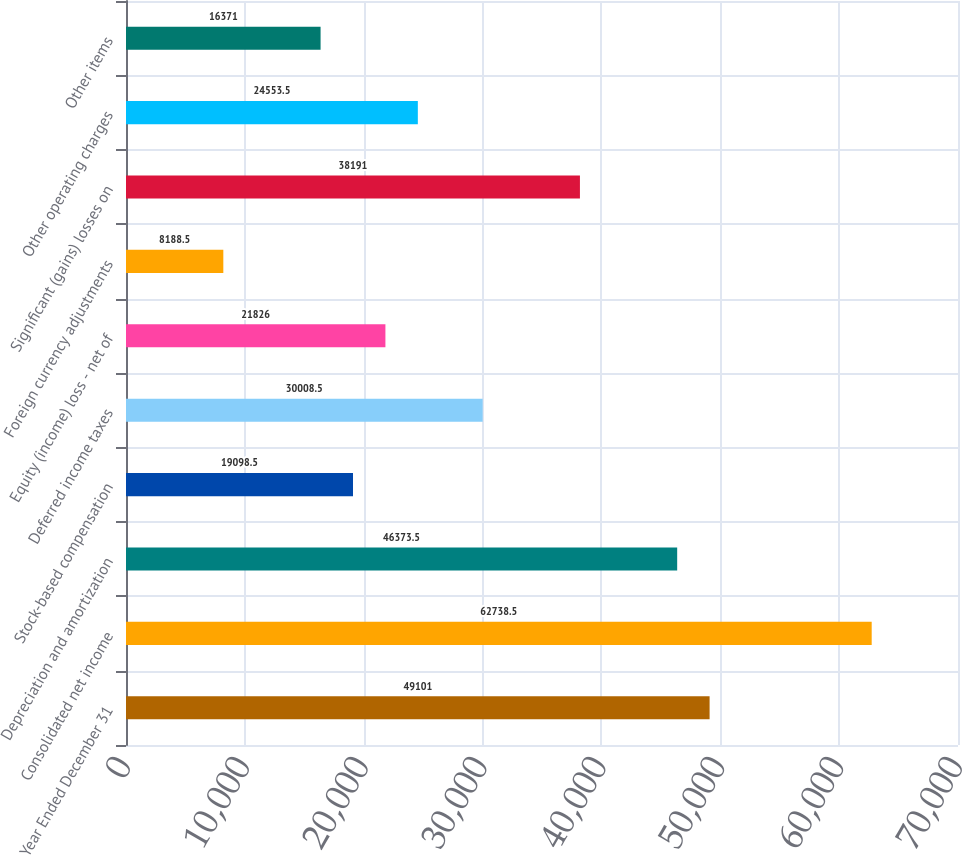<chart> <loc_0><loc_0><loc_500><loc_500><bar_chart><fcel>Year Ended December 31<fcel>Consolidated net income<fcel>Depreciation and amortization<fcel>Stock-based compensation<fcel>Deferred income taxes<fcel>Equity (income) loss - net of<fcel>Foreign currency adjustments<fcel>Significant (gains) losses on<fcel>Other operating charges<fcel>Other items<nl><fcel>49101<fcel>62738.5<fcel>46373.5<fcel>19098.5<fcel>30008.5<fcel>21826<fcel>8188.5<fcel>38191<fcel>24553.5<fcel>16371<nl></chart> 